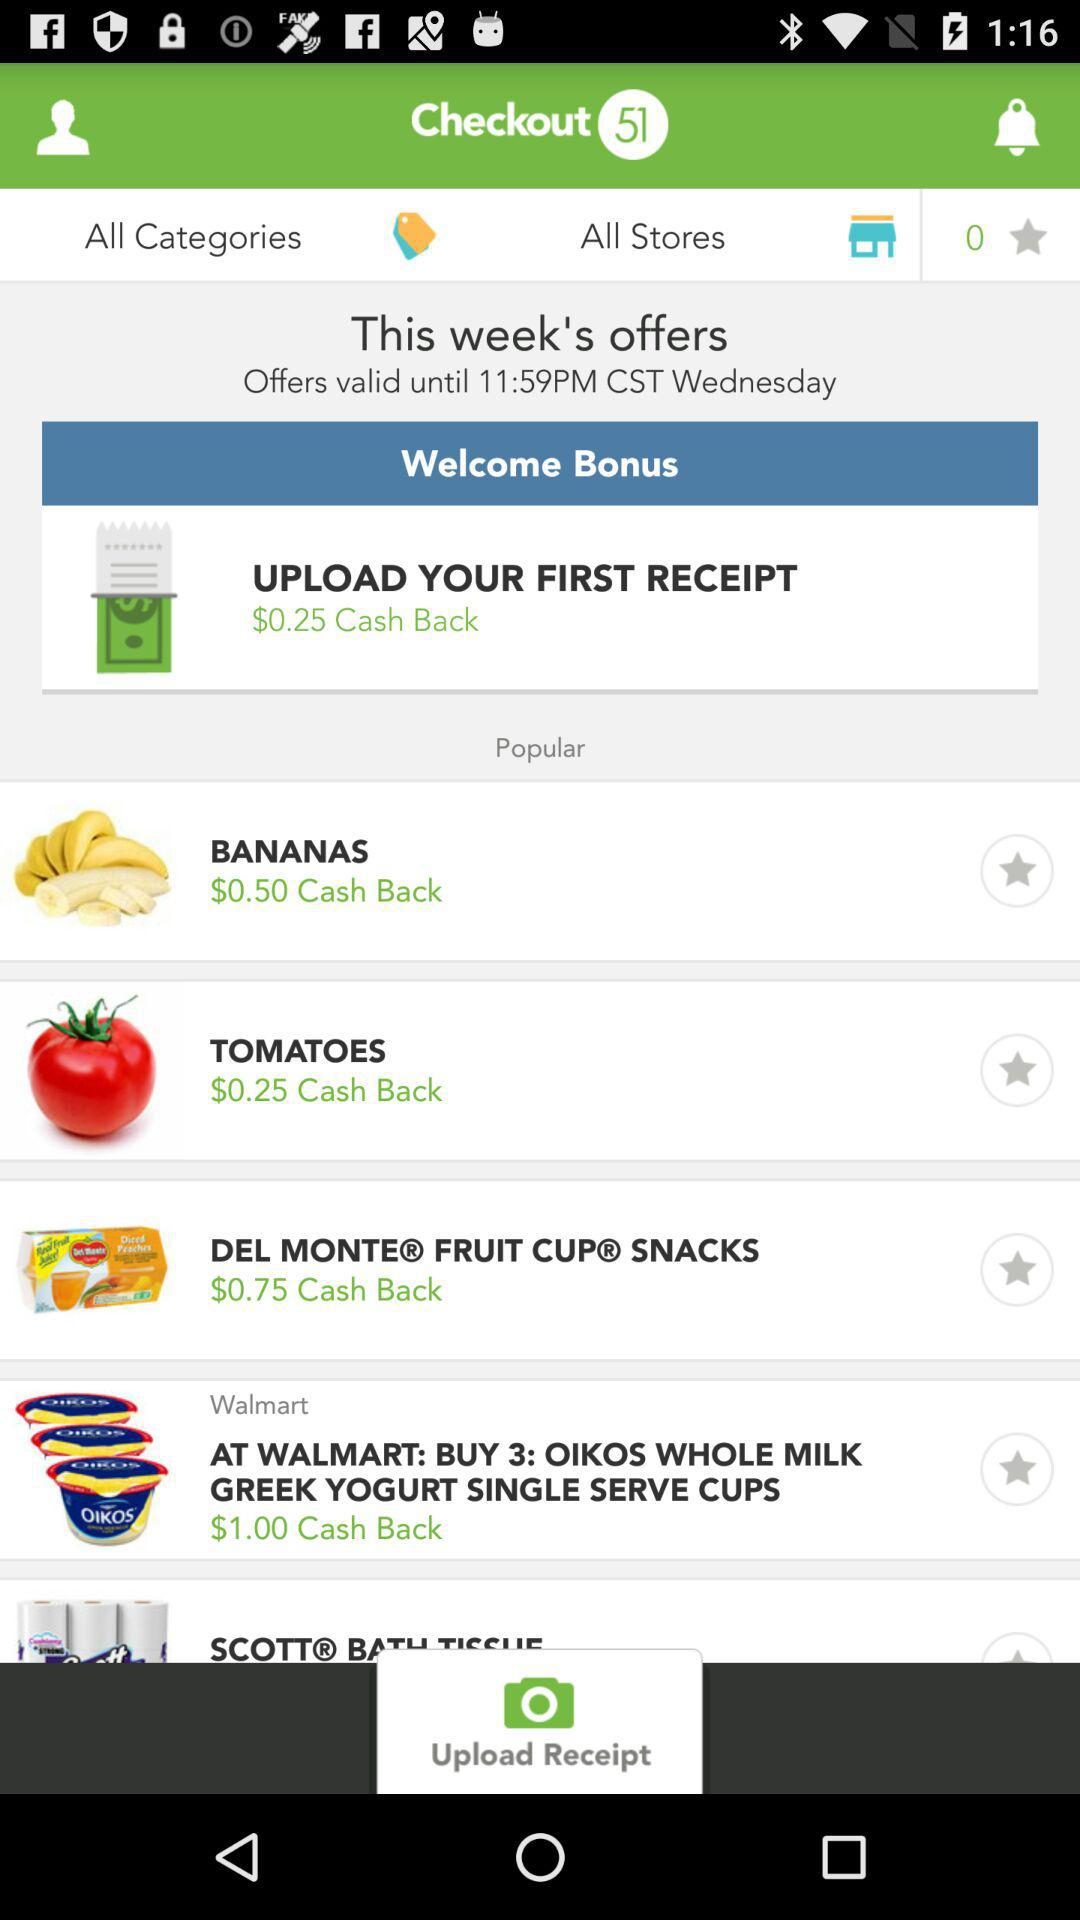How much cash back can I earn if I buy all the items on the screen?
Answer the question using a single word or phrase. $2.50 